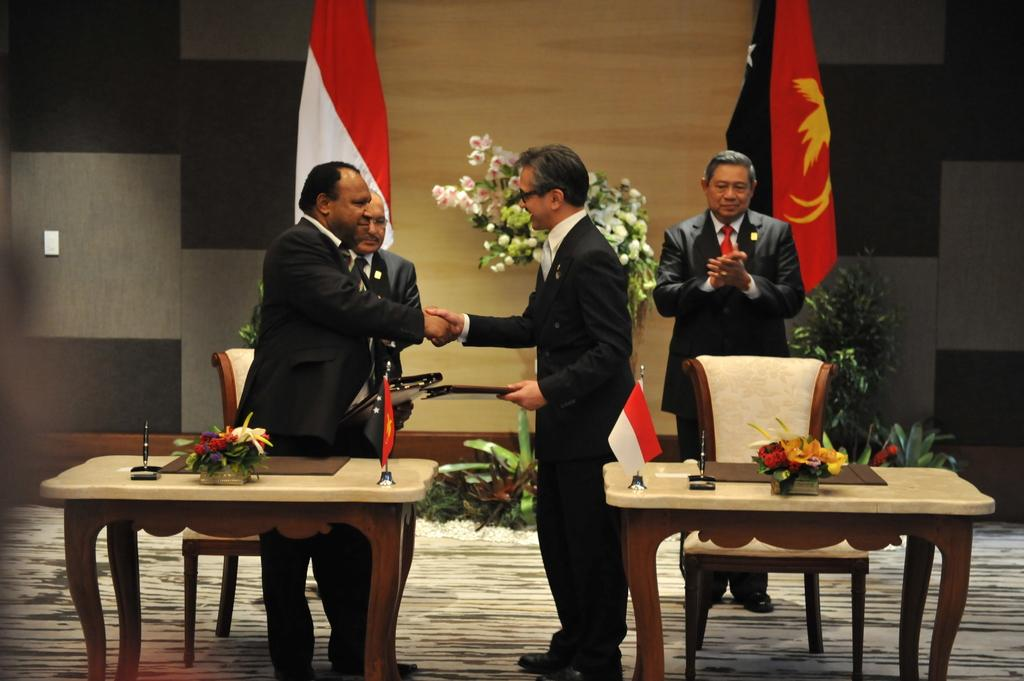What are the two people in the image doing? The two people in the image are shaking hands. Can you describe the man in the background? There is a man standing in the background. How many flags are visible in the image? There are two flags in the image. What level of cent is being suggested by the flags in the image? There is no mention of a cent or a suggestion in the image; it simply shows two people shaking hands and two flags. 